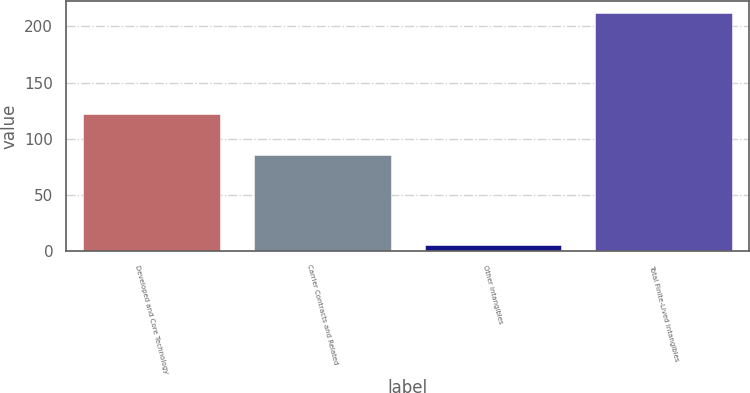<chart> <loc_0><loc_0><loc_500><loc_500><bar_chart><fcel>Developed and Core Technology<fcel>Carrier Contracts and Related<fcel>Other Intangibles<fcel>Total Finite-Lived Intangibles<nl><fcel>122<fcel>85<fcel>5<fcel>212<nl></chart> 